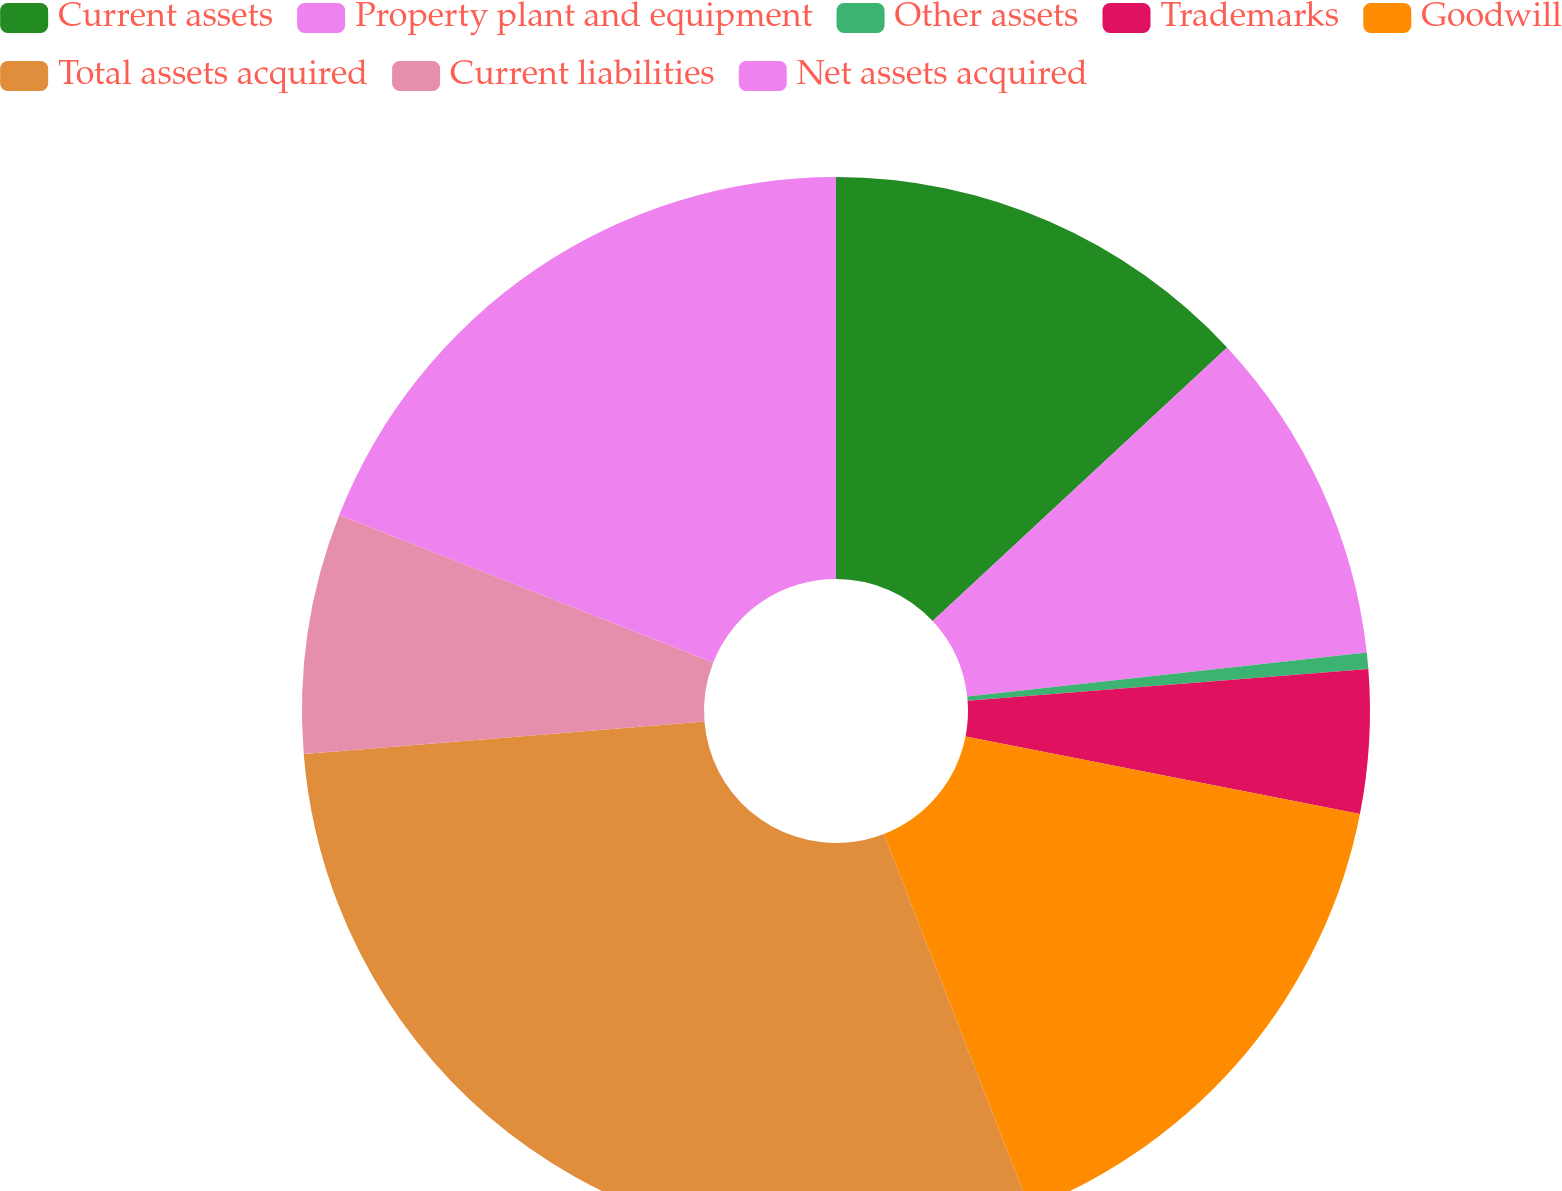Convert chart to OTSL. <chart><loc_0><loc_0><loc_500><loc_500><pie_chart><fcel>Current assets<fcel>Property plant and equipment<fcel>Other assets<fcel>Trademarks<fcel>Goodwill<fcel>Total assets acquired<fcel>Current liabilities<fcel>Net assets acquired<nl><fcel>13.08%<fcel>10.17%<fcel>0.5%<fcel>4.34%<fcel>16.0%<fcel>29.63%<fcel>7.26%<fcel>19.02%<nl></chart> 